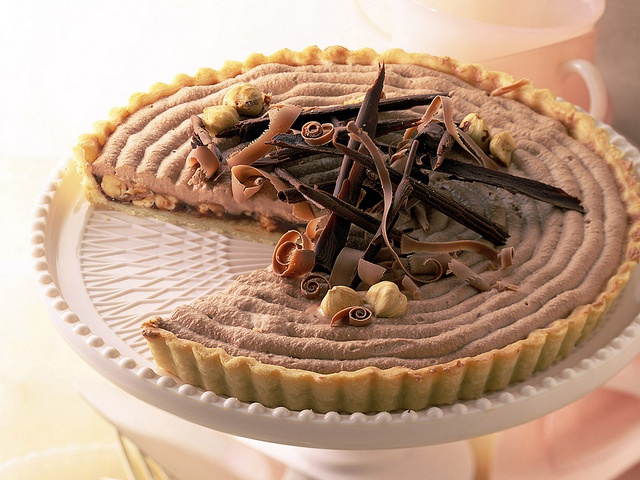Describe the objects in this image and their specific colors. I can see cake in white, brown, black, tan, and maroon tones, dining table in white and tan tones, and cup in white, tan, and lightgray tones in this image. 